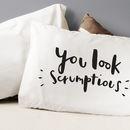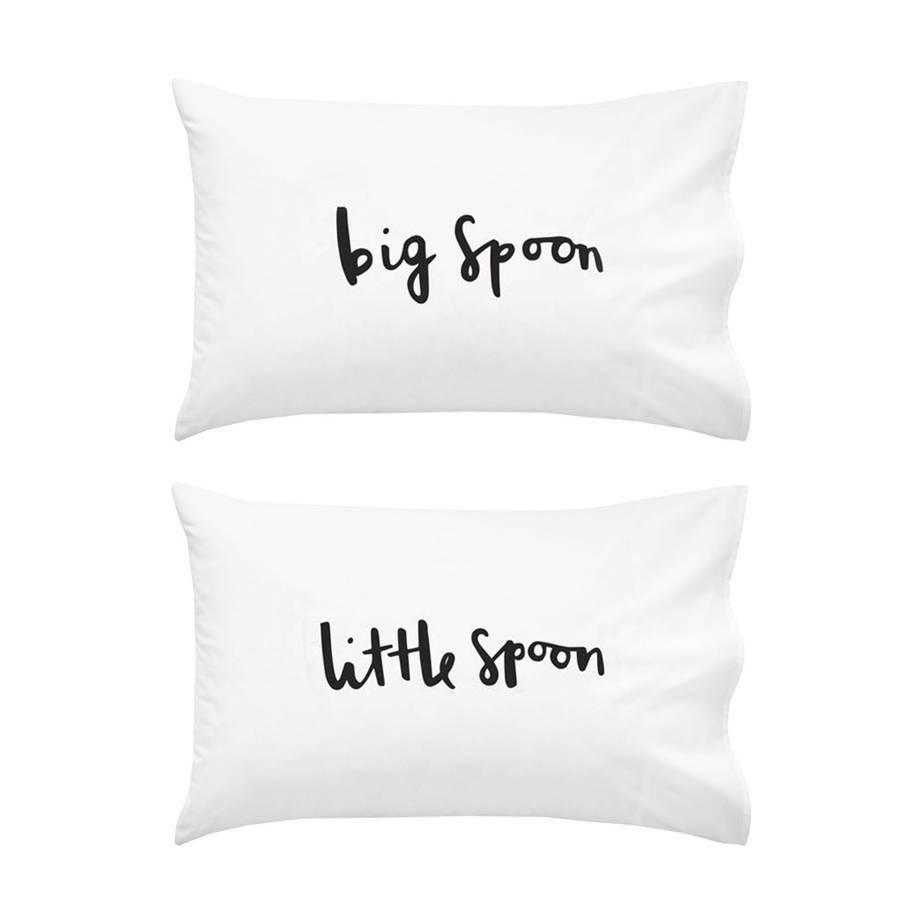The first image is the image on the left, the second image is the image on the right. Examine the images to the left and right. Is the description "Each image shows a pair of pillows with text only, side-by-side on a bed with all-white bedding." accurate? Answer yes or no. No. The first image is the image on the left, the second image is the image on the right. Considering the images on both sides, is "The writing in the right image is cursive." valid? Answer yes or no. Yes. 